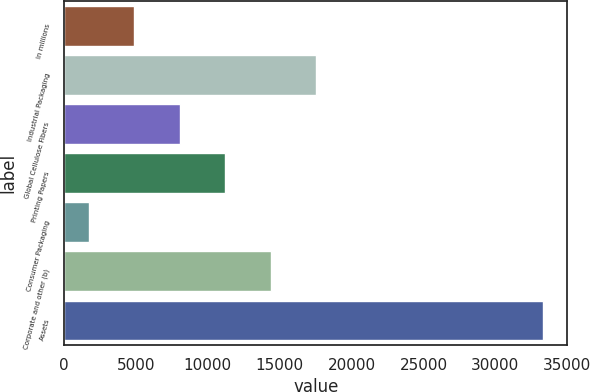Convert chart. <chart><loc_0><loc_0><loc_500><loc_500><bar_chart><fcel>In millions<fcel>Industrial Packaging<fcel>Global Cellulose Fibers<fcel>Printing Papers<fcel>Consumer Packaging<fcel>Corporate and other (b)<fcel>Assets<nl><fcel>4896.9<fcel>17540.5<fcel>8057.8<fcel>11218.7<fcel>1736<fcel>14379.6<fcel>33345<nl></chart> 